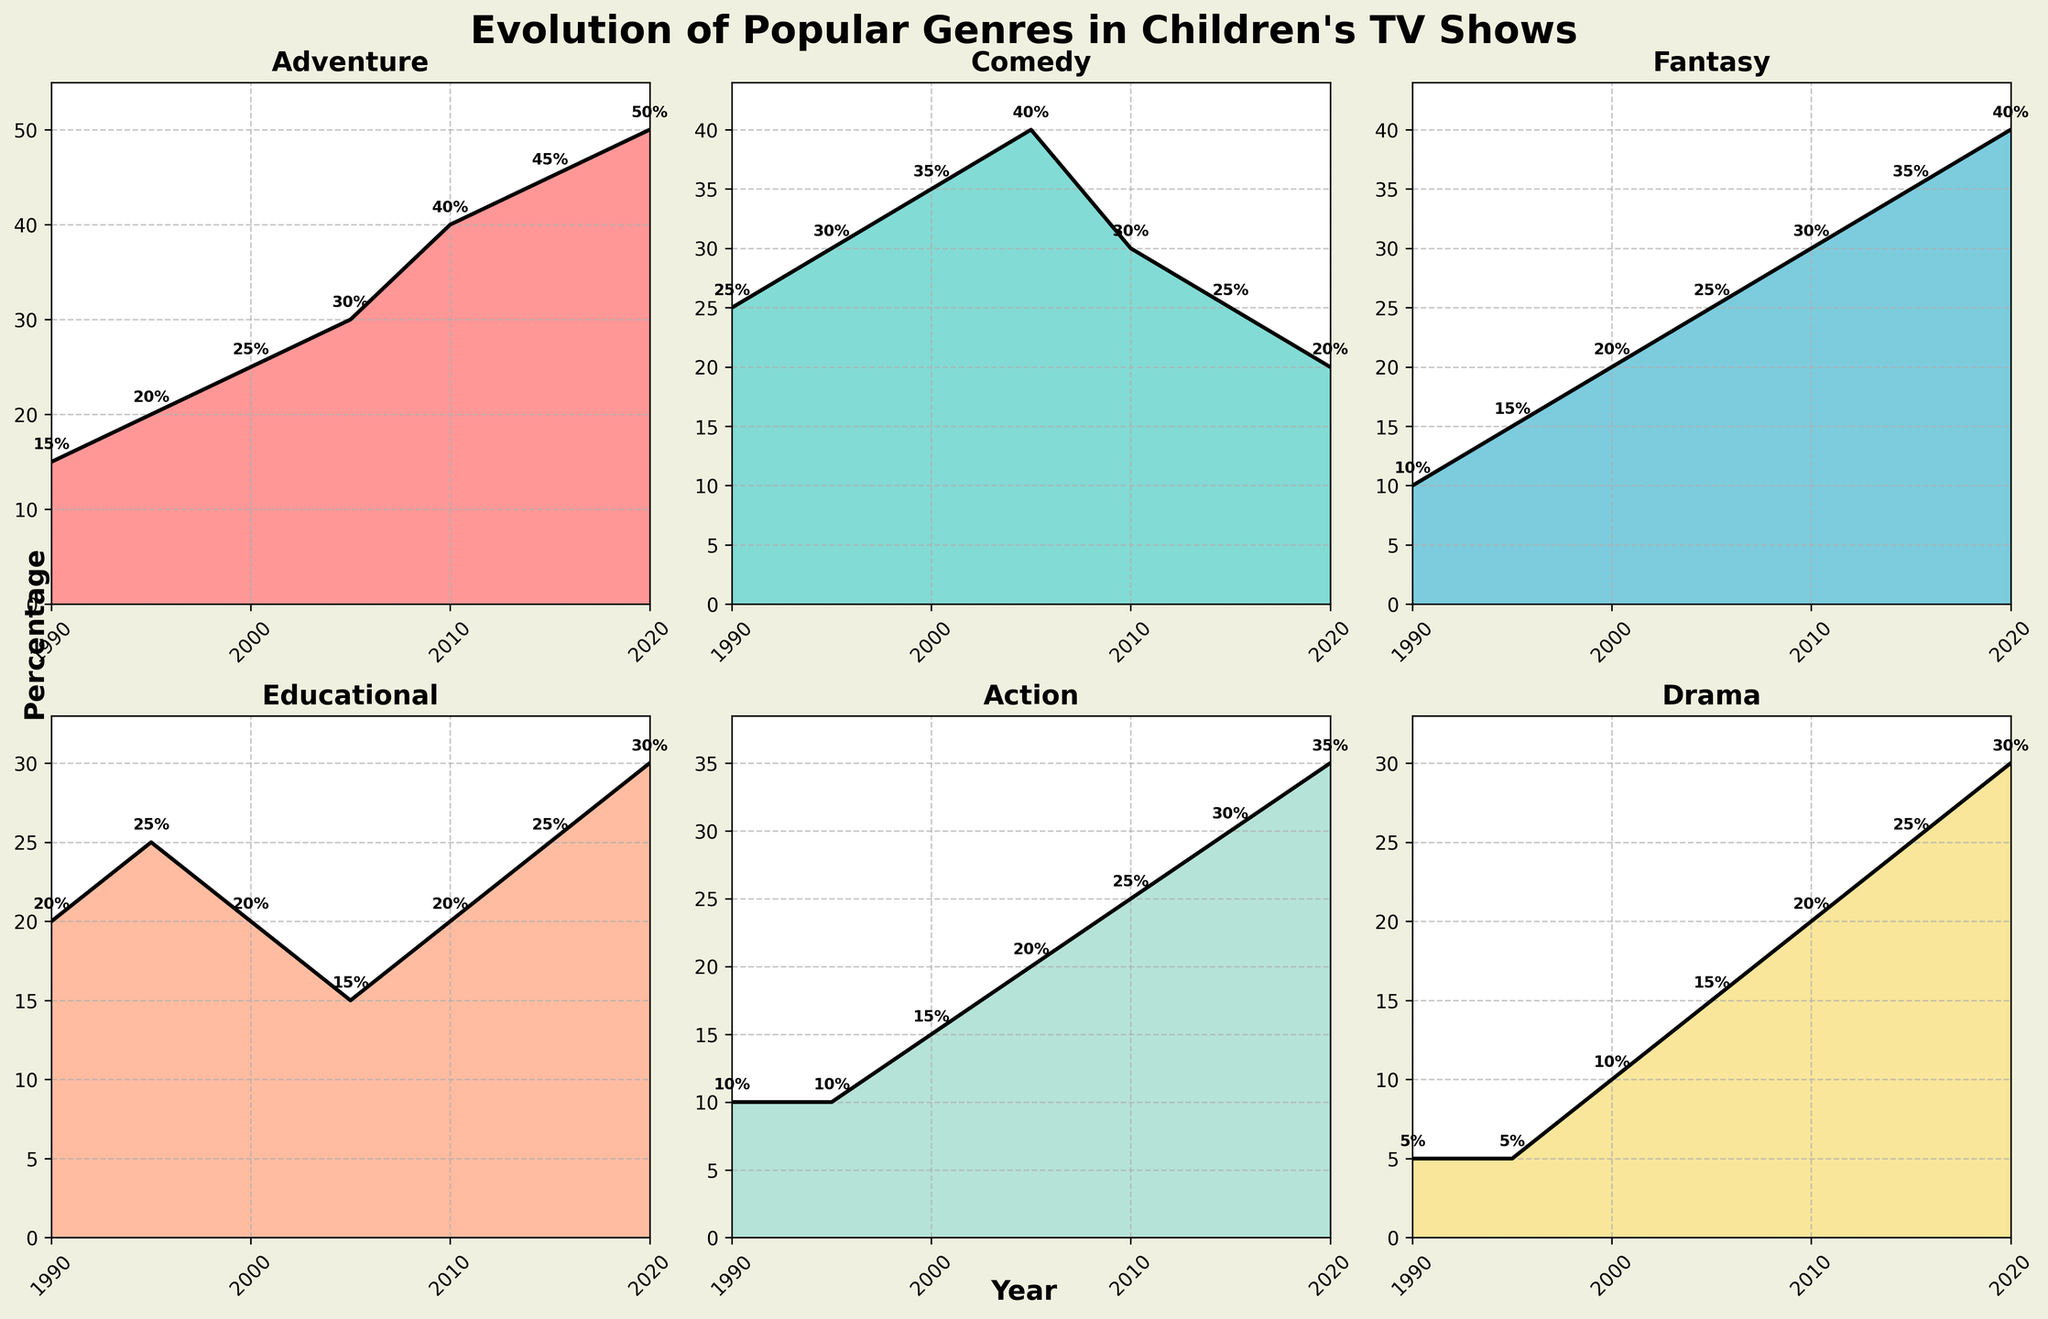What is the title of the figure? The title is displayed at the top of the figure and indicates the main topic of the visual information. It reads "Evolution of Popular Genres in Children's TV Shows".
Answer: Evolution of Popular Genres in Children's TV Shows How many genres are represented in the figure? There are six subplots in the figure, each representing a different genre. Tag lines in each subplot indicate genre names such as Adventure, Comedy, Fantasy, Educational, Action, and Drama.
Answer: 6 Which genre shows the highest percentage increase from 1990 to 2020? By observing the subplots for each genre, you can visually compare the starting and ending values. Adventure starts at 15% in 1990 and ends at 50% in 2020, which is an increase of 35%. This is the highest increase among all genres.
Answer: Adventure In which year does Fantasy have the same percentage as Drama? By looking at the subplots of both Fantasy and Drama, you see that their curves intersect at the value of 20% in the year 2010.
Answer: 2010 Which genre had its lowest percentage in the year 2020? Comparing the end points (2020) of all genre plots, you notice that Comedy has the lowest percentage at 20%.
Answer: Comedy What is the average percentage of the Drama genre from 1990 to 2020? First, sum the Drama values over the years (5, 5, 10, 15, 20, 25, 30) which equals 110. Divide this by the number of years (7) to get the average percentage, which is approximately 15.7.
Answer: 15.7 Between 2005 and 2015, which genre saw the largest decrease in percentage? By comparing the values from 2005 to 2015, Comedy decreases from 40% to 25%, a drop of 15%, which is the largest decrease among all genres.
Answer: Comedy What percentage did Educational shows achieve in the year 2000? Looking at the subplot for Educational shows, the value at the year 2000 is labeled 20%.
Answer: 20% How many times does the Adventure genre intersect with the Action genre over the years displayed? Checking the subplots of both Adventure and Action, you see that their paths cross one time, which is around the year 2010.
Answer: 1 In which years does Comedy have more than 30% of the total? Observing the plot for Comedy and its corresponding percentages, the plot crosses the 30% line at the years 1995 and 2000.
Answer: 1995, 2000 